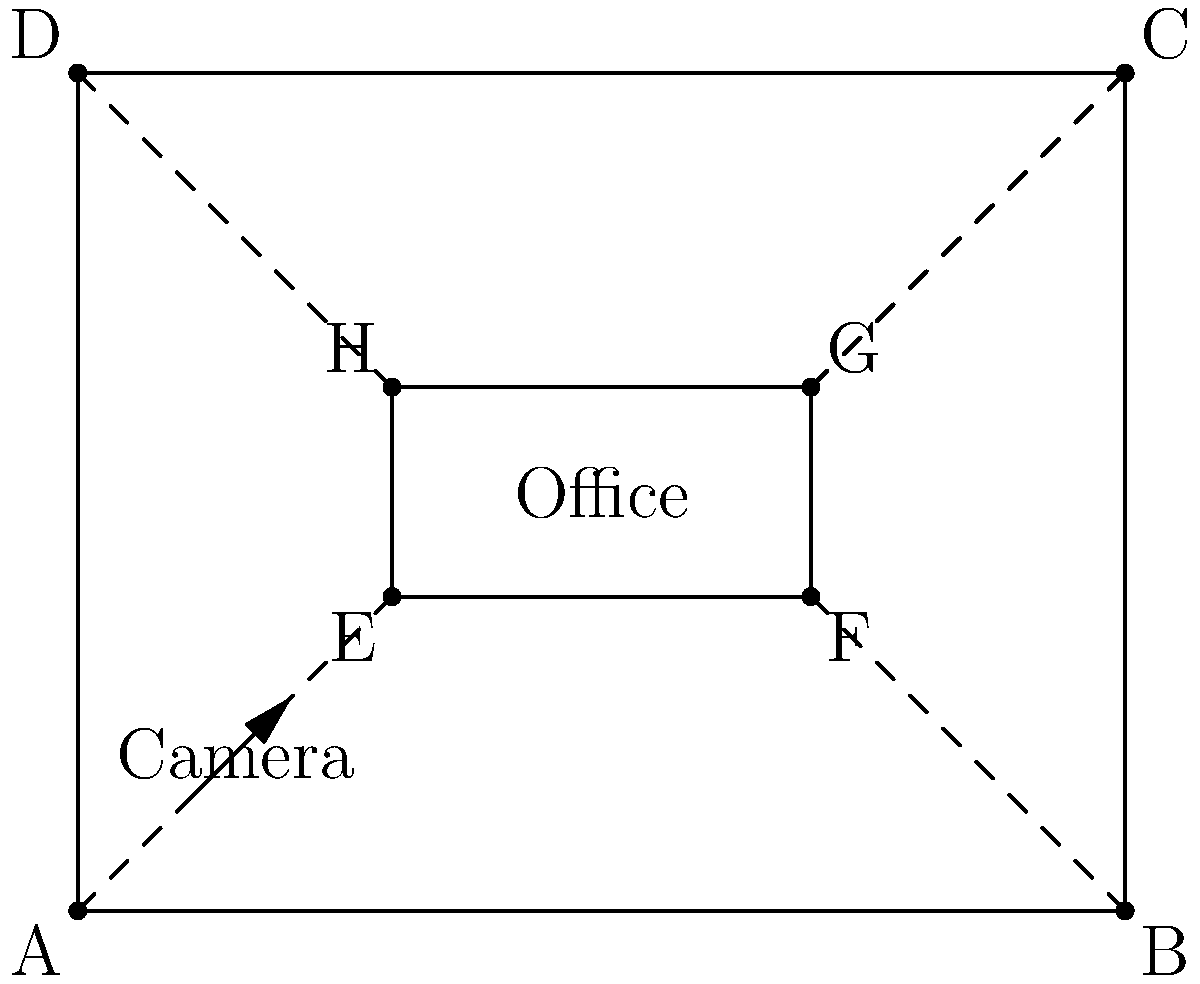In a rectangular office floor measuring 10m by 8m, security cameras need to be installed at the corners to cover the entire area. Each camera has a 90° field of view. What is the minimum number of cameras required to ensure complete coverage of the office space, assuming no obstructions? To solve this problem, we'll follow these steps:

1) First, we need to understand that a 90° field of view from a corner will cover a quarter of the rectangular floor.

2) The office floor is a rectangle, which has four corners.

3) If we place a camera at each corner with its 90° field of view directed inward:
   - The camera at corner A will cover the bottom-left quarter
   - The camera at corner B will cover the bottom-right quarter
   - The camera at corner C will cover the top-right quarter
   - The camera at corner D will cover the top-left quarter

4) With these four cameras, we can cover the entire office floor without any blind spots.

5) Using fewer than four cameras would leave some areas uncovered:
   - With 3 cameras, at least one quarter of the office would be uncovered
   - With 2 cameras, at least half of the office would be uncovered
   - With 1 camera, at most a quarter of the office would be covered

Therefore, the minimum number of cameras required is 4.
Answer: 4 cameras 